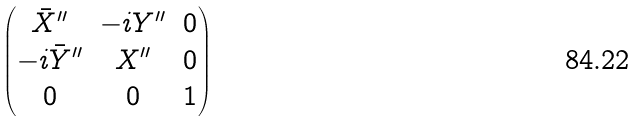<formula> <loc_0><loc_0><loc_500><loc_500>\begin{pmatrix} \bar { X } ^ { \prime \prime } & - i Y ^ { \prime \prime } & 0 \\ - i \bar { Y } ^ { \prime \prime } & X ^ { \prime \prime } & 0 \\ 0 & 0 & 1 \end{pmatrix}</formula> 